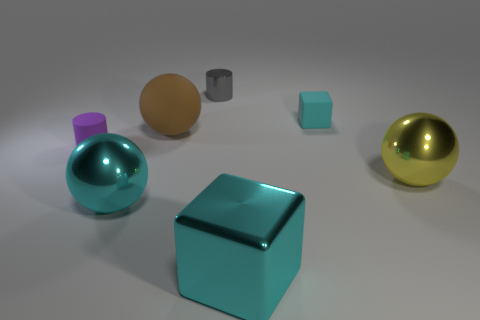Add 2 small metallic cylinders. How many objects exist? 9 Subtract all cylinders. How many objects are left? 5 Add 3 small purple rubber things. How many small purple rubber things exist? 4 Subtract 1 brown balls. How many objects are left? 6 Subtract all big cyan matte cylinders. Subtract all tiny purple cylinders. How many objects are left? 6 Add 4 rubber cylinders. How many rubber cylinders are left? 5 